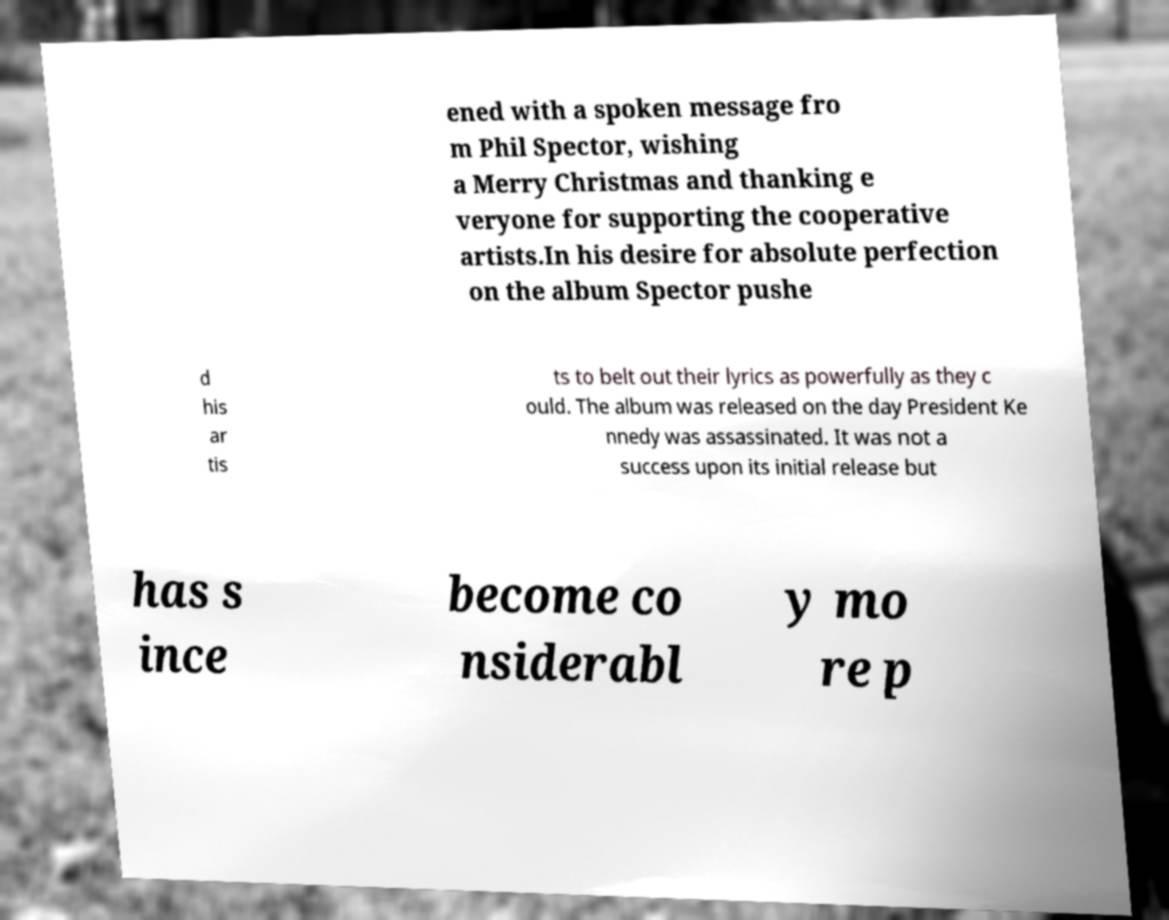There's text embedded in this image that I need extracted. Can you transcribe it verbatim? ened with a spoken message fro m Phil Spector, wishing a Merry Christmas and thanking e veryone for supporting the cooperative artists.In his desire for absolute perfection on the album Spector pushe d his ar tis ts to belt out their lyrics as powerfully as they c ould. The album was released on the day President Ke nnedy was assassinated. It was not a success upon its initial release but has s ince become co nsiderabl y mo re p 